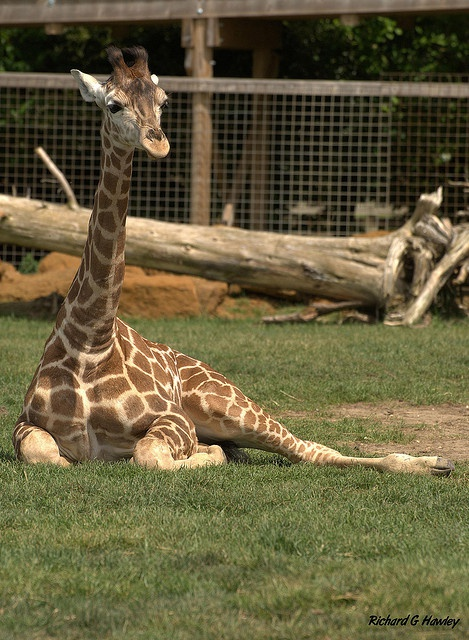Describe the objects in this image and their specific colors. I can see a giraffe in black, maroon, and gray tones in this image. 